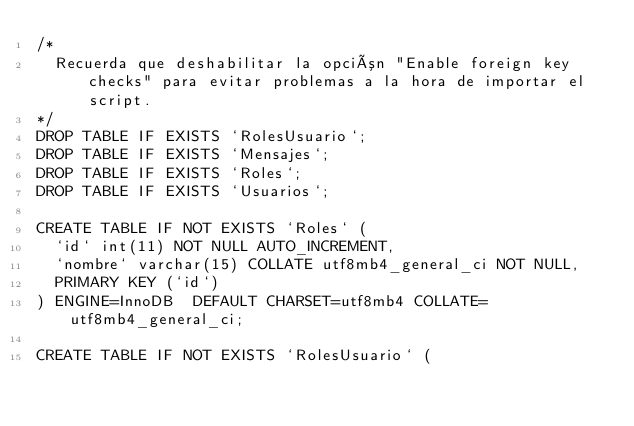<code> <loc_0><loc_0><loc_500><loc_500><_SQL_>/*
  Recuerda que deshabilitar la opción "Enable foreign key checks" para evitar problemas a la hora de importar el script.
*/
DROP TABLE IF EXISTS `RolesUsuario`;
DROP TABLE IF EXISTS `Mensajes`;
DROP TABLE IF EXISTS `Roles`;
DROP TABLE IF EXISTS `Usuarios`;

CREATE TABLE IF NOT EXISTS `Roles` (
  `id` int(11) NOT NULL AUTO_INCREMENT,
  `nombre` varchar(15) COLLATE utf8mb4_general_ci NOT NULL,
  PRIMARY KEY (`id`)
) ENGINE=InnoDB  DEFAULT CHARSET=utf8mb4 COLLATE=utf8mb4_general_ci;

CREATE TABLE IF NOT EXISTS `RolesUsuario` (</code> 